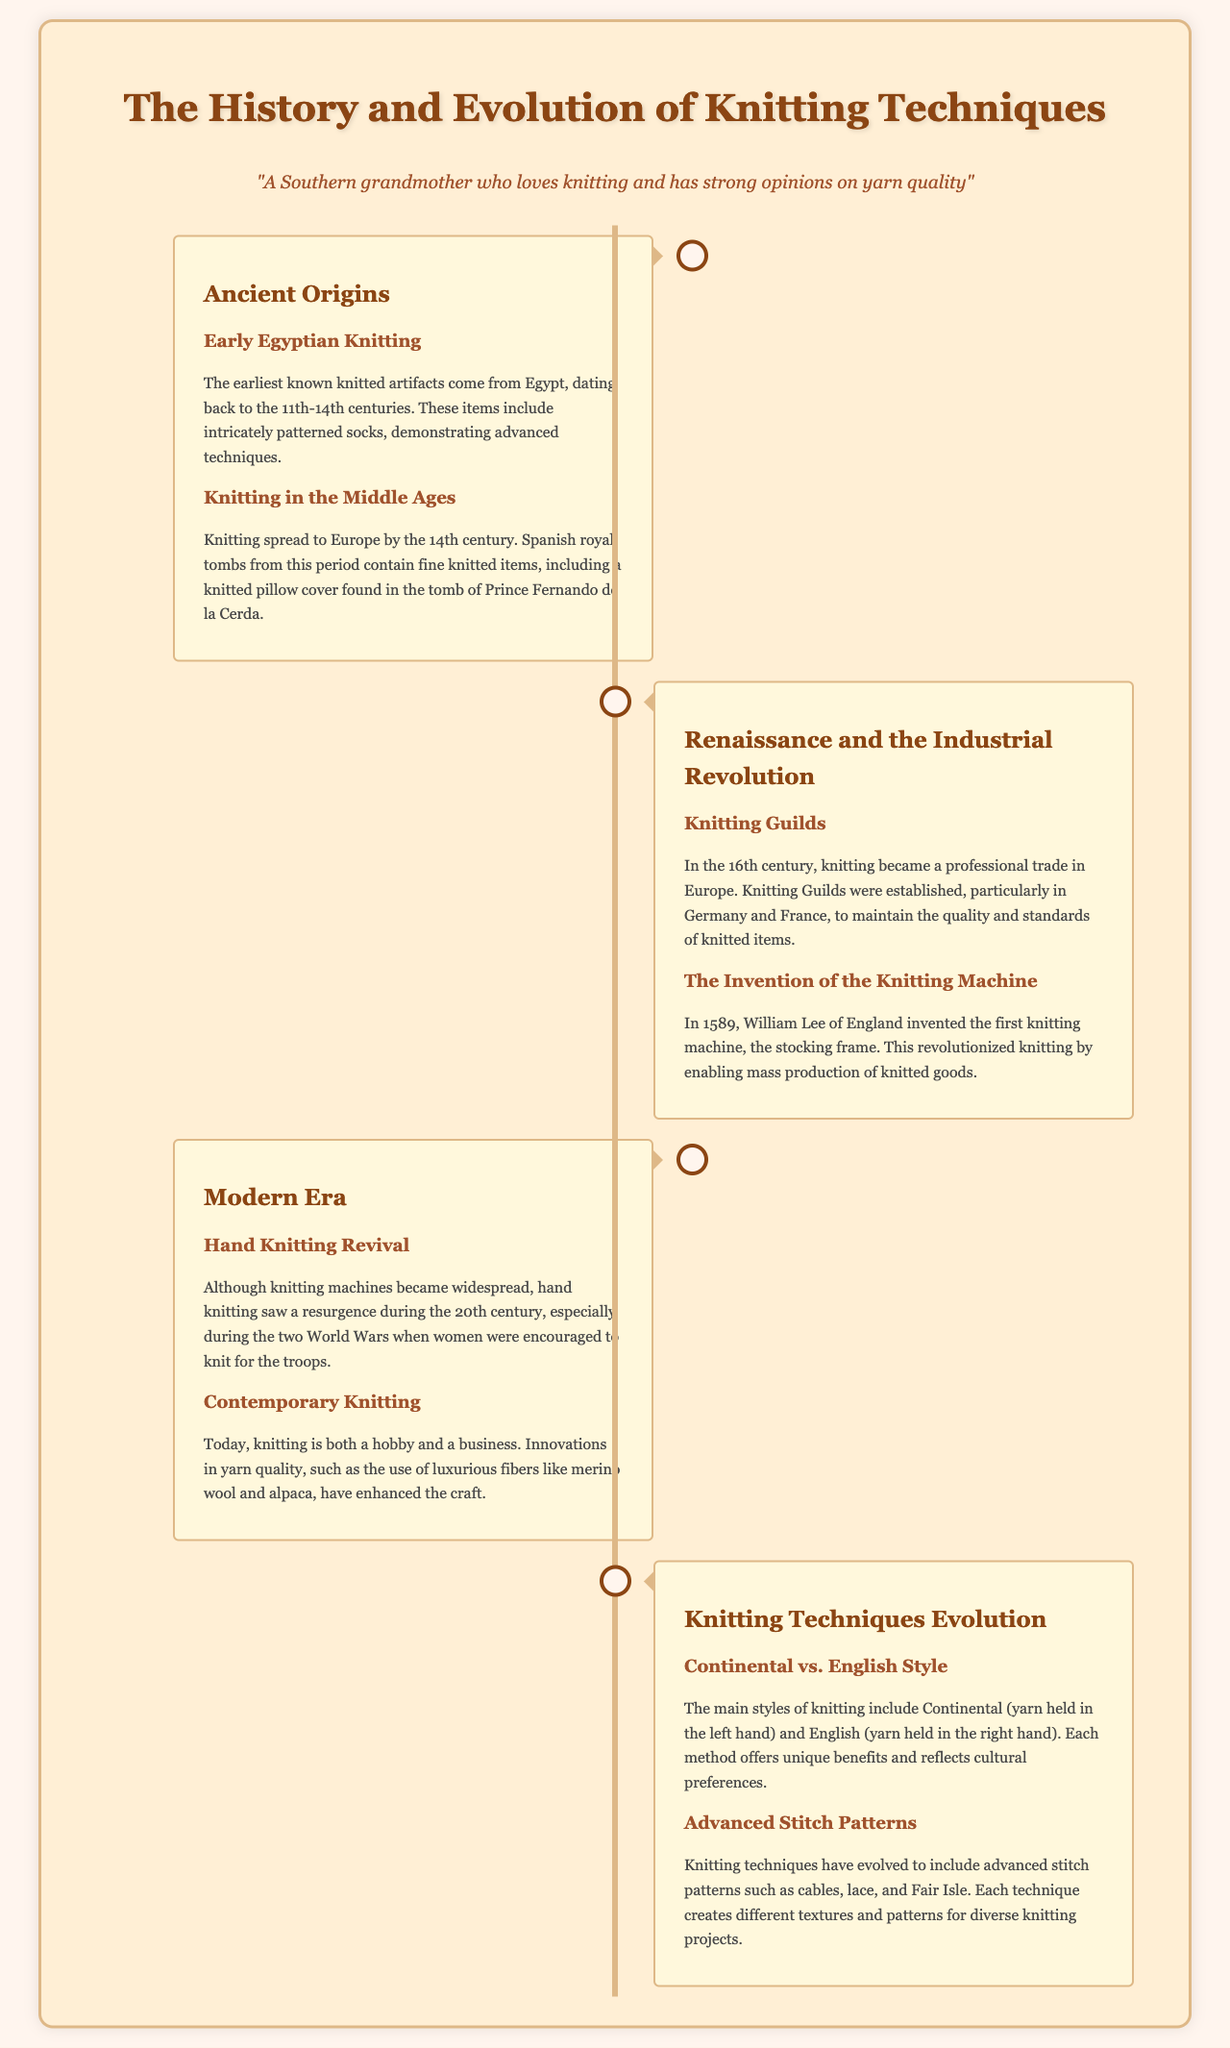What are the earliest known knitted artifacts? The document states the earliest known knitted artifacts come from Egypt.
Answer: Egypt Which century did knitting spread to Europe? The document mentions knitting spread to Europe by the 14th century.
Answer: 14th century Who invented the first knitting machine? According to the document, William Lee invented the first knitting machine.
Answer: William Lee What significant event encouraged hand knitting during the 20th century? The document discusses how the two World Wars encouraged women to knit for the troops.
Answer: World Wars What are the two main knitting styles mentioned? The document lists Continental and English as the main knitting styles.
Answer: Continental and English What luxurious fibers have enhanced the craft of knitting today? The document refers to luxurious fibers like merino wool and alpaca.
Answer: merino wool and alpaca Which knitting technique creates different textures and patterns? The document explains that advanced stitch patterns like cables, lace, and Fair Isle create different textures and patterns.
Answer: cables, lace, and Fair Isle What was the role of Knitting Guilds in the 16th century? The document states that Knitting Guilds maintained the quality and standards of knitted items.
Answer: Maintain quality and standards When did the hand knitting revival occur? The document characterizes the hand knitting revival as occurring during the 20th century.
Answer: 20th century 